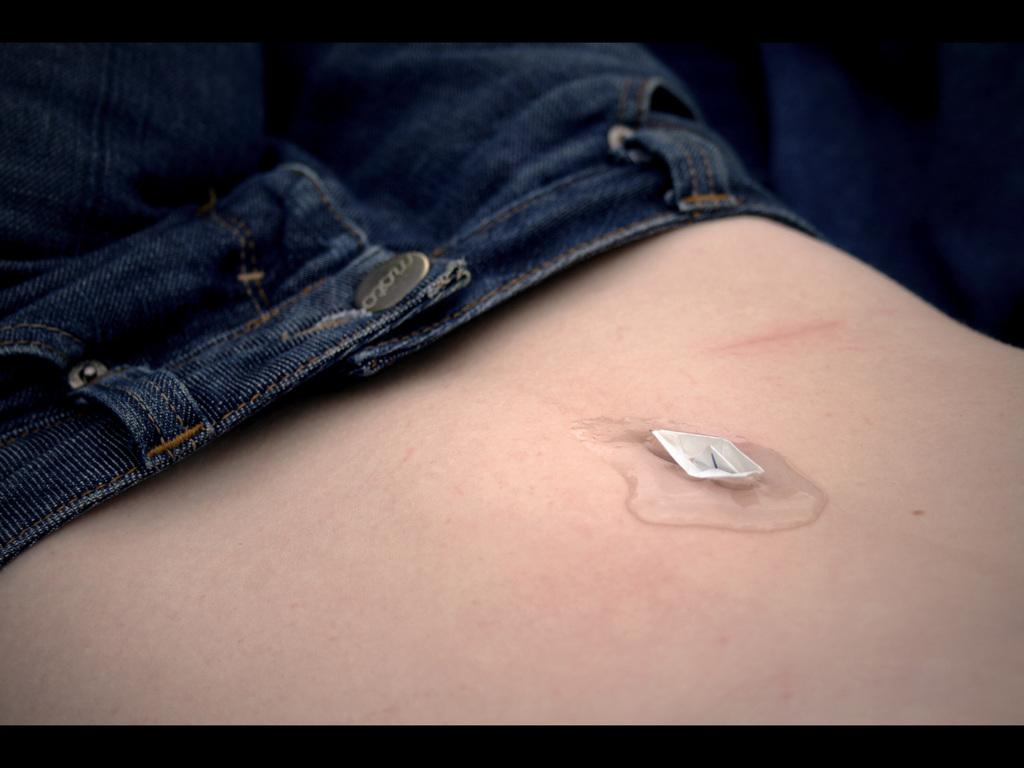What is present in the image? There is a person in the image. What type of clothing is the person wearing? The person is wearing jeans. What object can be seen in the image besides the person? There is a paper boat in the image. What discovery was made on the road in the image? There is no road or discovery mentioned in the image; it only features a person wearing jeans and a paper boat. 